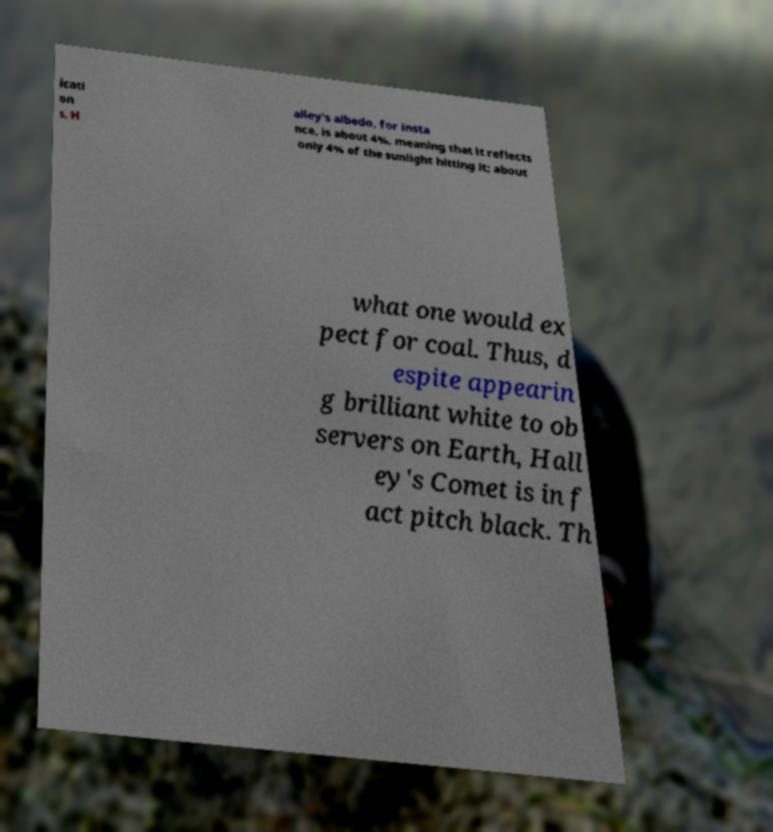What messages or text are displayed in this image? I need them in a readable, typed format. icati on s. H alley's albedo, for insta nce, is about 4%, meaning that it reflects only 4% of the sunlight hitting it; about what one would ex pect for coal. Thus, d espite appearin g brilliant white to ob servers on Earth, Hall ey's Comet is in f act pitch black. Th 